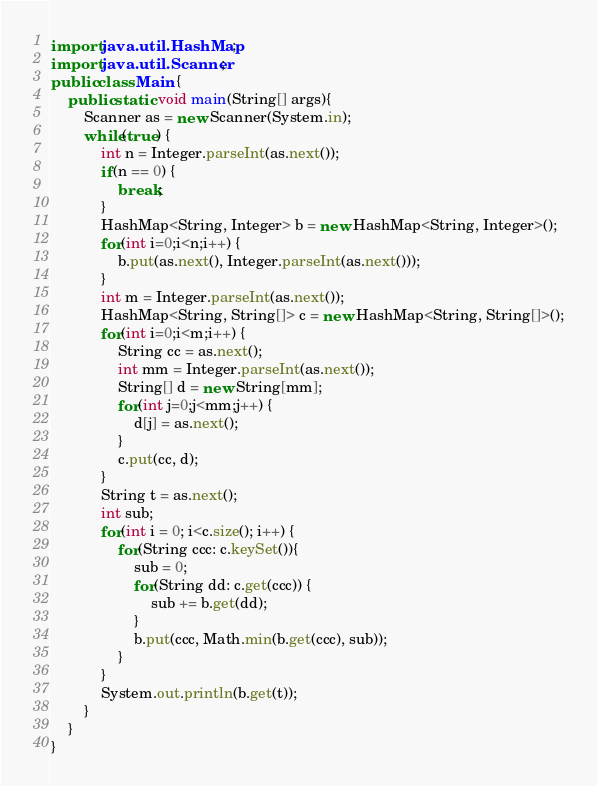Convert code to text. <code><loc_0><loc_0><loc_500><loc_500><_Java_>import java.util.HashMap;
import java.util.Scanner;
public class Main {
	public static void main(String[] args){
		Scanner as = new Scanner(System.in);
		while(true) {
			int n = Integer.parseInt(as.next());
			if(n == 0) {
				break;
			}
			HashMap<String, Integer> b = new HashMap<String, Integer>();
			for(int i=0;i<n;i++) {
				b.put(as.next(), Integer.parseInt(as.next()));
			}
			int m = Integer.parseInt(as.next());
			HashMap<String, String[]> c = new HashMap<String, String[]>();
			for(int i=0;i<m;i++) {
				String cc = as.next();
				int mm = Integer.parseInt(as.next());
				String[] d = new String[mm];
				for(int j=0;j<mm;j++) {
					d[j] = as.next();
				}
				c.put(cc, d);
			}
			String t = as.next();
			int sub;
			for(int i = 0; i<c.size(); i++) {
				for(String ccc: c.keySet()){
					sub = 0;
					for(String dd: c.get(ccc)) {
						sub += b.get(dd);
					}
					b.put(ccc, Math.min(b.get(ccc), sub));
				}
			}
			System.out.println(b.get(t));
		}
	}
}
</code> 